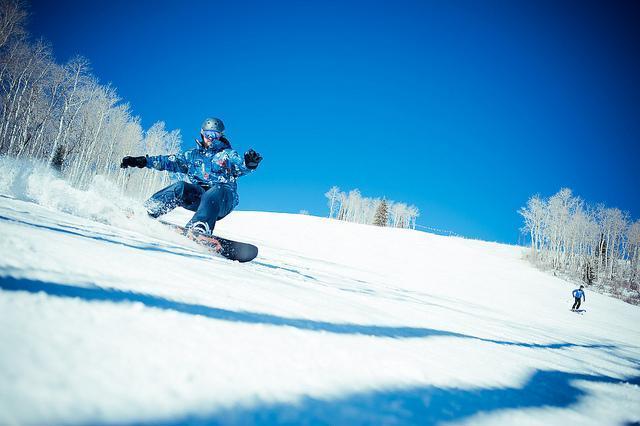How many black cars are there?
Give a very brief answer. 0. 